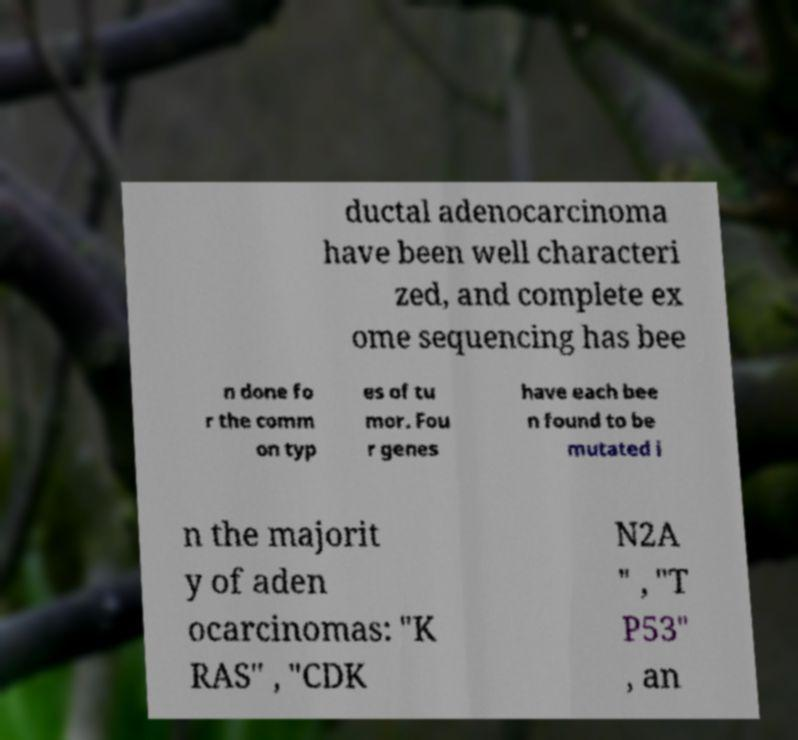Could you assist in decoding the text presented in this image and type it out clearly? ductal adenocarcinoma have been well characteri zed, and complete ex ome sequencing has bee n done fo r the comm on typ es of tu mor. Fou r genes have each bee n found to be mutated i n the majorit y of aden ocarcinomas: "K RAS" , "CDK N2A " , "T P53" , an 